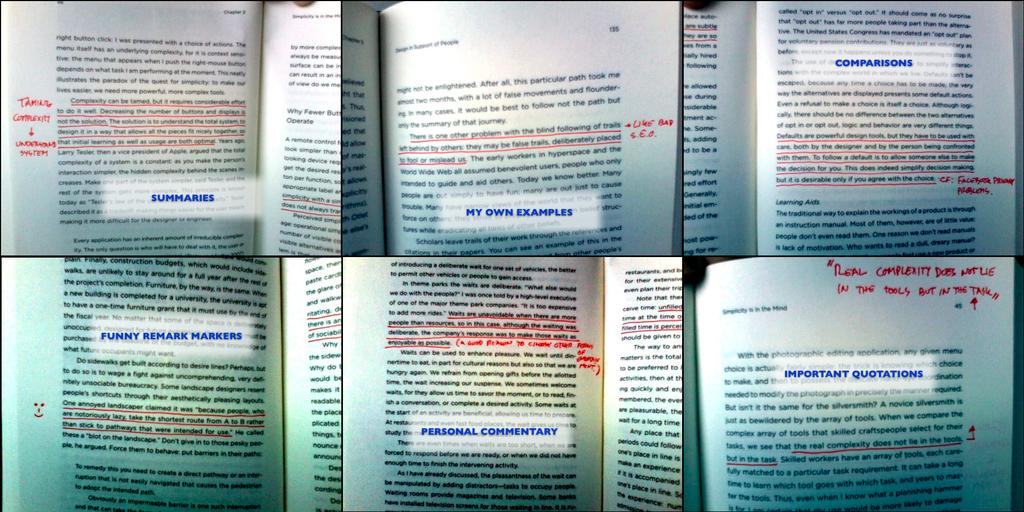Provide a one-sentence caption for the provided image. You can find everything from Summaries to Important Quotations in the open pages of this book. 